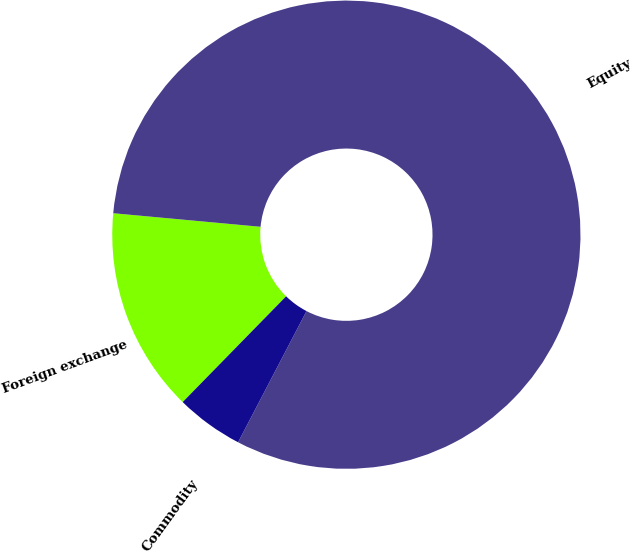<chart> <loc_0><loc_0><loc_500><loc_500><pie_chart><fcel>Foreign exchange<fcel>Equity<fcel>Commodity<nl><fcel>14.14%<fcel>81.19%<fcel>4.67%<nl></chart> 